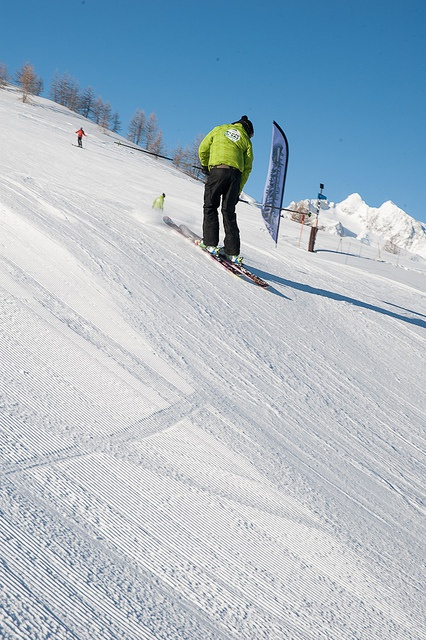Describe the objects in this image and their specific colors. I can see people in gray, black, darkgreen, olive, and khaki tones, skis in gray, darkgray, black, and lightgray tones, people in gray, beige, darkgray, lightgray, and olive tones, and people in gray, black, darkgray, and maroon tones in this image. 